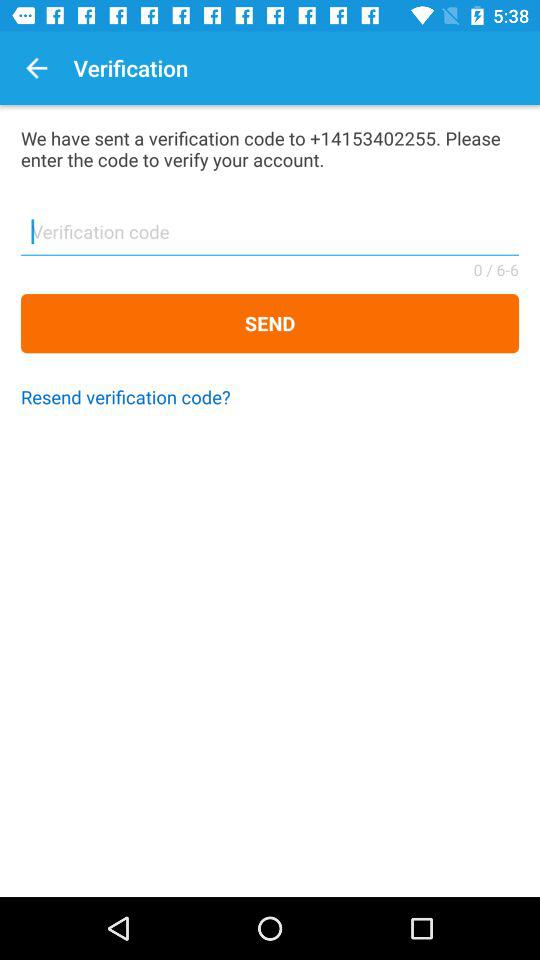What is the verification code?
When the provided information is insufficient, respond with <no answer>. <no answer> 